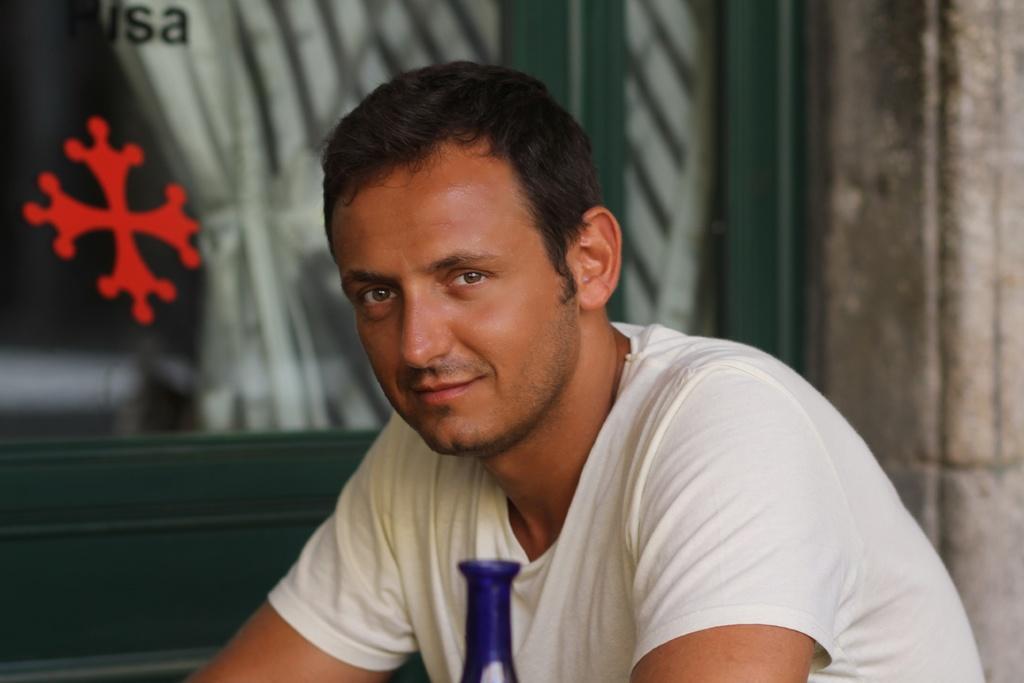Can you describe this image briefly? In this image there is a person staring, behind the person there is a wooden door with a glass on it. 